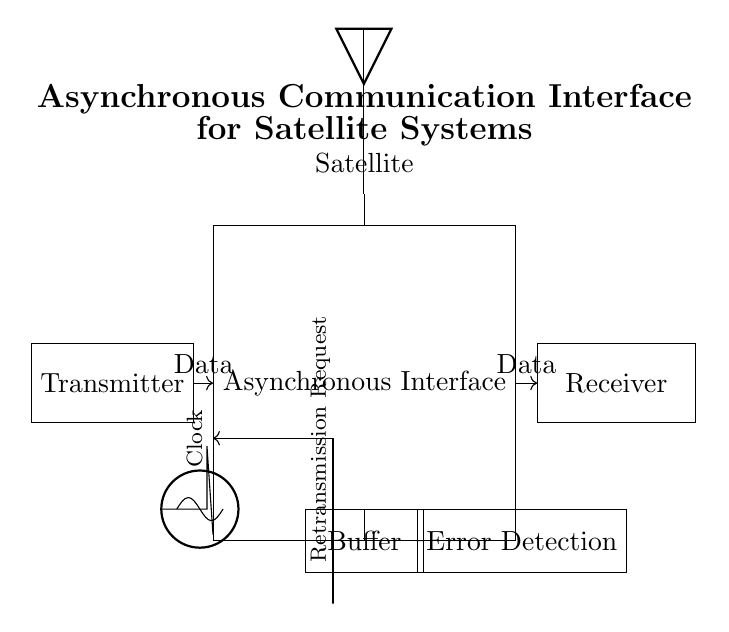What components are present in this circuit? The circuit contains a transmitter, asynchronous interface, receiver, clock, buffer, error detection module, and antenna. These are all represented by labeled rectangles.
Answer: transmitter, asynchronous interface, receiver, clock, buffer, error detection, antenna What does the buffer do in this circuit? The buffer temporarily stores data between the asynchronous interface and error detection to manage data flow and ensure proper timing. It acts as an intermediary to prevent data loss during transmission.
Answer: manage data flow How is the data transmitted from the transmitter to the receiver? Data is sent from the transmitter to the asynchronous interface through a direct arrow indicating data flow, and then from the asynchronous interface to the receiver in the same manner.
Answer: through arrows What role does error detection play in this circuit? Error detection identifies any inconsistencies in data transmission, requesting a retransmission if errors are found. The feedback connection indicates this process back to the asynchronous interface for corrective action.
Answer: identify inconsistencies What is the purpose of the clock in the circuit? The clock provides timing signals that synchronize the data transmission process. It ensures that data is processed at consistent intervals to align transmission between components.
Answer: synchronize data transmission What type of communication does this circuit employ? This circuit employs asynchronous communication, which allows data to be sent without a shared clock signal, relying instead on start and stop bits to manage data flow.
Answer: asynchronous communication How does the retransmission request mechanism work in this circuit? The retransmission request mechanism is represented by a feedback connection from the error detection module back to the asynchronous interface, indicating that if an error is detected, a request to resend the data will occur.
Answer: feedback connection 